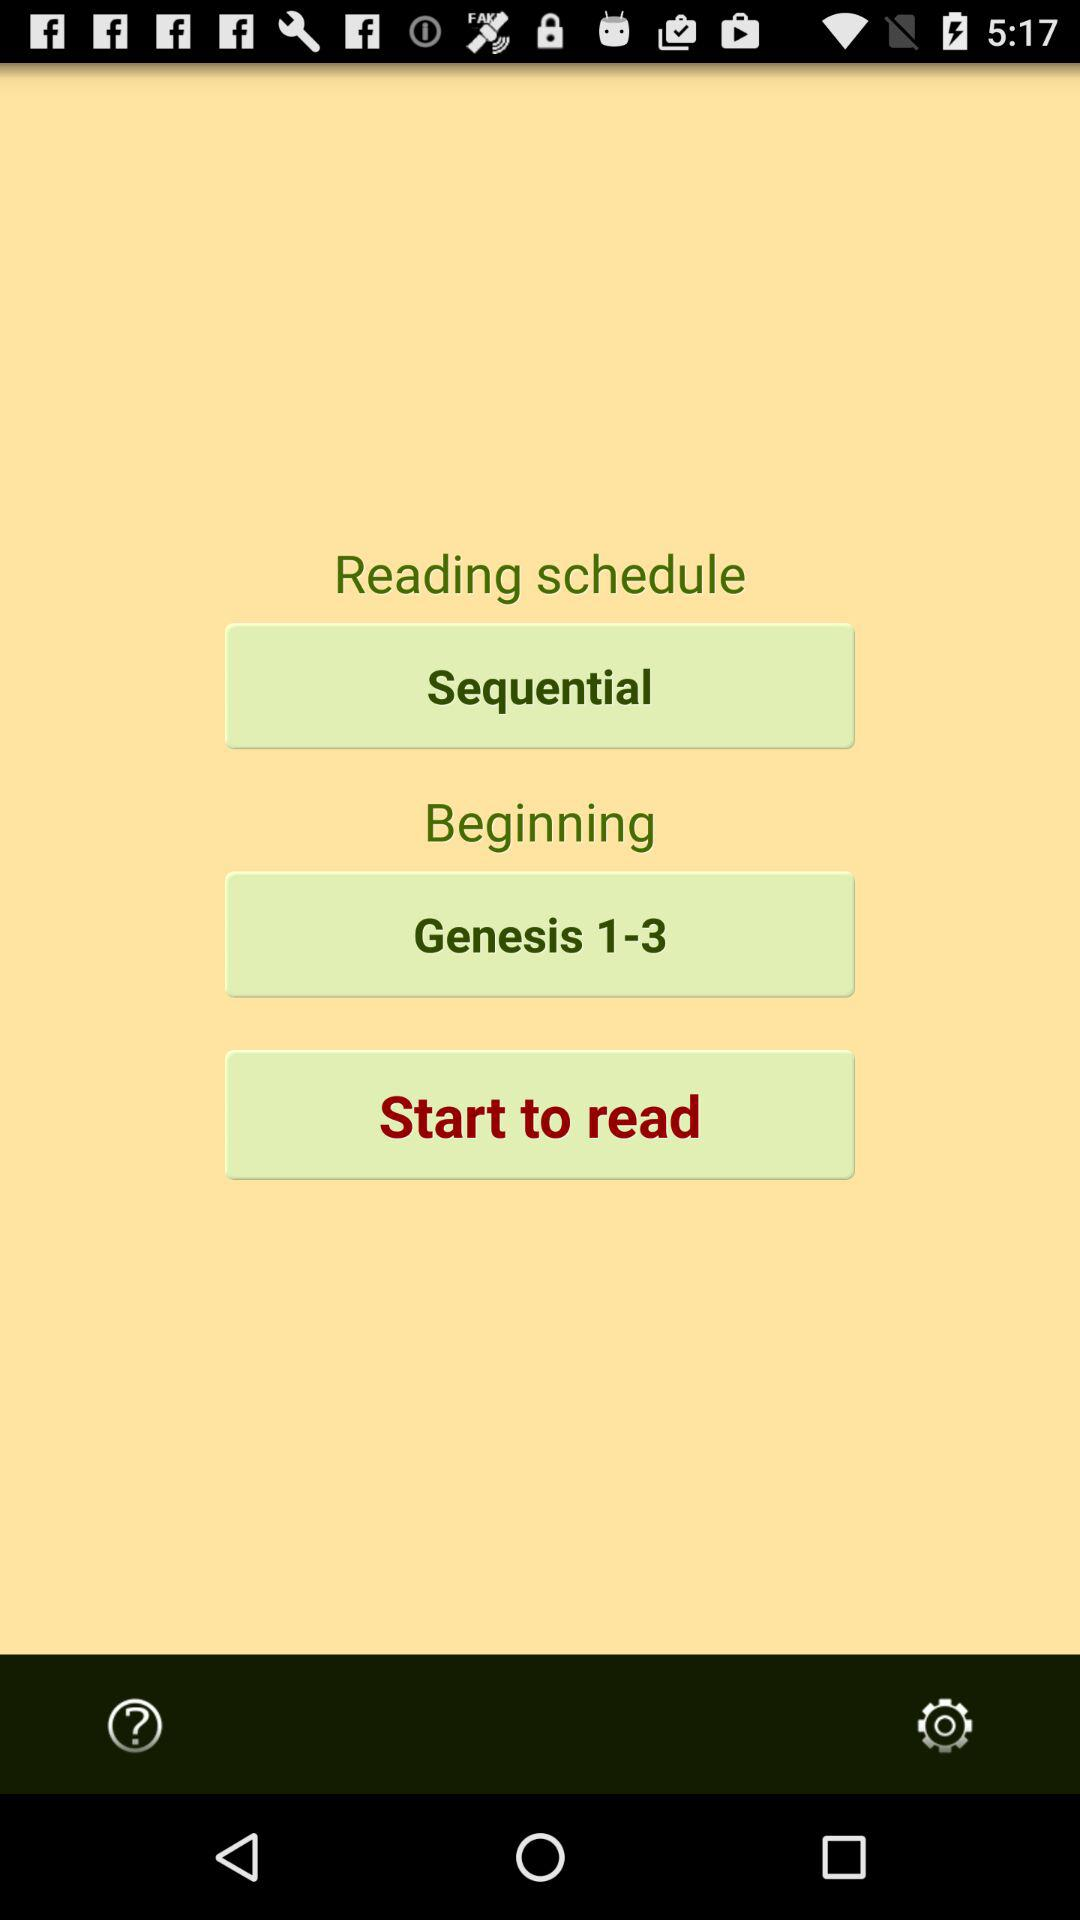From where will the reading begin? The reading will begin from "Genesis 1-3". 